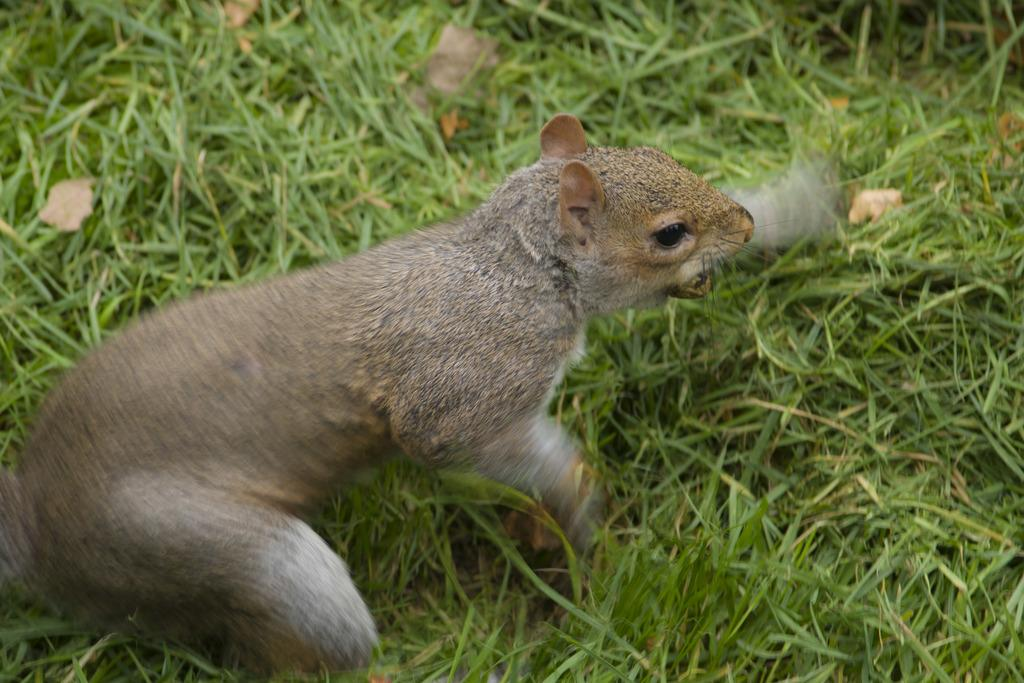What type of animal is in the image? There is a fox squirrel in the image. Where is the fox squirrel located in the image? The fox squirrel is in the front of the image. What type of vegetation is at the bottom of the image? There is grass at the bottom of the image. What is the fox squirrel's belief about the noise in the image? There is no noise present in the image, so it is not possible to determine the fox squirrel's belief about it. 